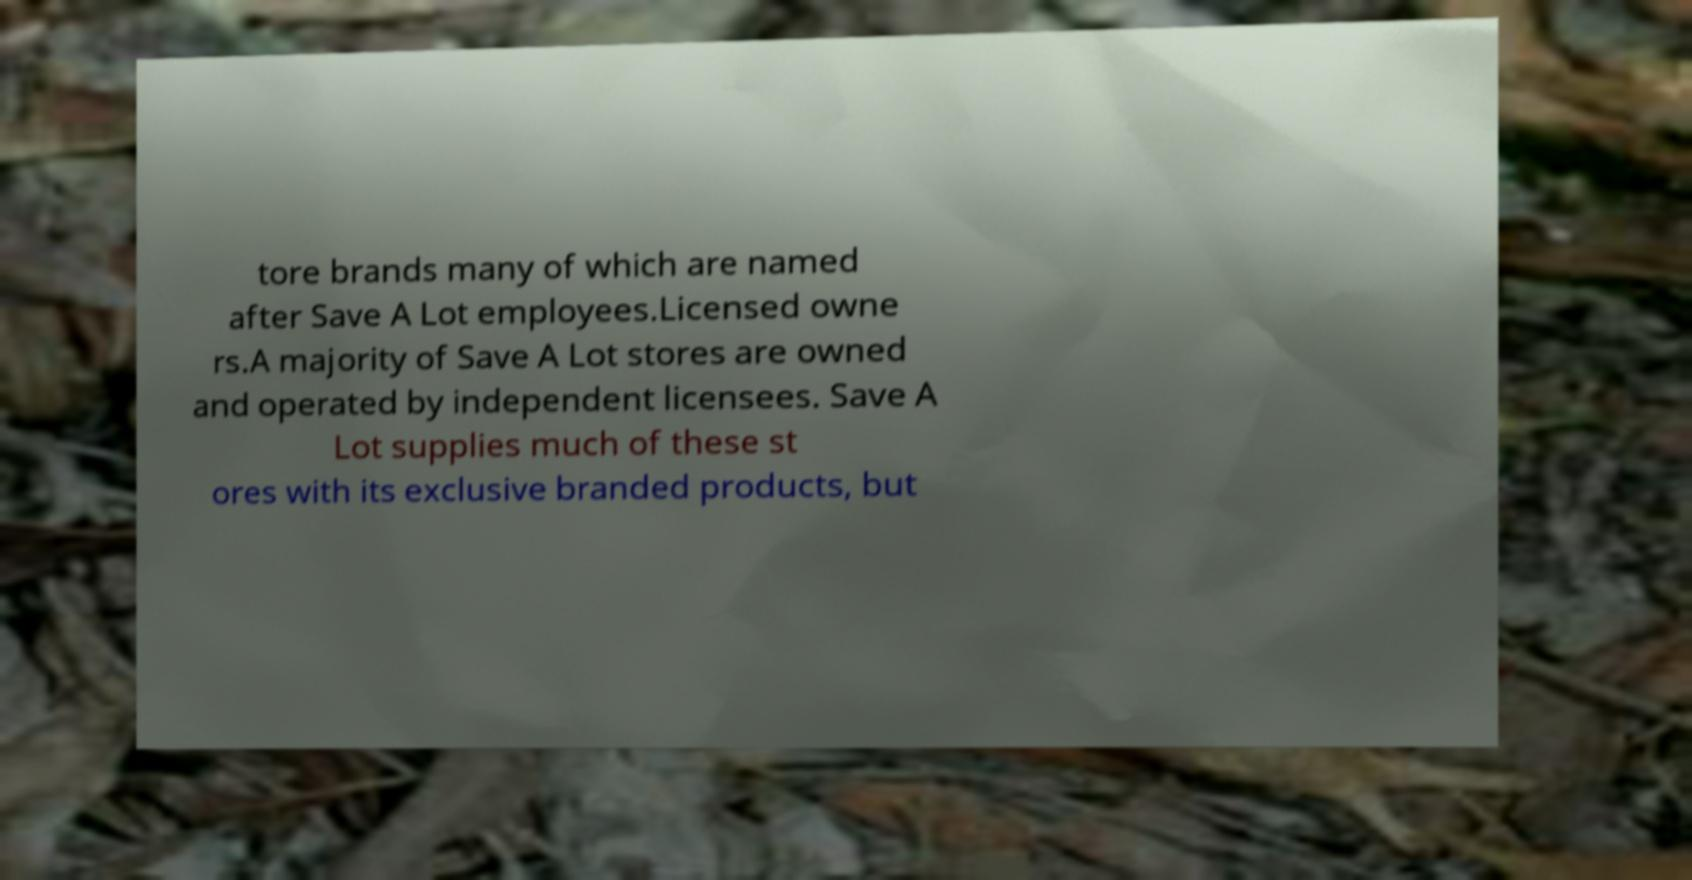What messages or text are displayed in this image? I need them in a readable, typed format. tore brands many of which are named after Save A Lot employees.Licensed owne rs.A majority of Save A Lot stores are owned and operated by independent licensees. Save A Lot supplies much of these st ores with its exclusive branded products, but 